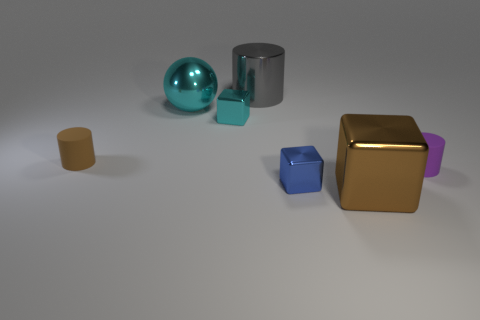There is a gray thing that is the same size as the cyan metal ball; what is its shape?
Give a very brief answer. Cylinder. Are there any big metal objects to the right of the large cyan object?
Provide a succinct answer. Yes. Is the size of the metallic ball the same as the gray shiny cylinder?
Keep it short and to the point. Yes. There is a small thing on the right side of the blue metallic thing; what shape is it?
Provide a succinct answer. Cylinder. Is there a brown shiny object of the same size as the cyan shiny cube?
Offer a terse response. No. There is a purple thing that is the same size as the brown rubber cylinder; what is it made of?
Make the answer very short. Rubber. What is the size of the block on the right side of the blue shiny cube?
Make the answer very short. Large. The metal cylinder is what size?
Provide a short and direct response. Large. Do the purple rubber thing and the cylinder that is behind the shiny sphere have the same size?
Give a very brief answer. No. There is a sphere behind the large shiny thing that is on the right side of the big gray thing; what is its color?
Your answer should be compact. Cyan. 